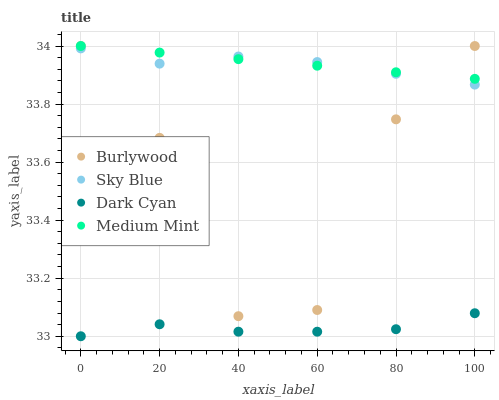Does Dark Cyan have the minimum area under the curve?
Answer yes or no. Yes. Does Medium Mint have the maximum area under the curve?
Answer yes or no. Yes. Does Sky Blue have the minimum area under the curve?
Answer yes or no. No. Does Sky Blue have the maximum area under the curve?
Answer yes or no. No. Is Medium Mint the smoothest?
Answer yes or no. Yes. Is Burlywood the roughest?
Answer yes or no. Yes. Is Sky Blue the smoothest?
Answer yes or no. No. Is Sky Blue the roughest?
Answer yes or no. No. Does Dark Cyan have the lowest value?
Answer yes or no. Yes. Does Sky Blue have the lowest value?
Answer yes or no. No. Does Medium Mint have the highest value?
Answer yes or no. Yes. Does Sky Blue have the highest value?
Answer yes or no. No. Is Dark Cyan less than Sky Blue?
Answer yes or no. Yes. Is Medium Mint greater than Dark Cyan?
Answer yes or no. Yes. Does Sky Blue intersect Burlywood?
Answer yes or no. Yes. Is Sky Blue less than Burlywood?
Answer yes or no. No. Is Sky Blue greater than Burlywood?
Answer yes or no. No. Does Dark Cyan intersect Sky Blue?
Answer yes or no. No. 